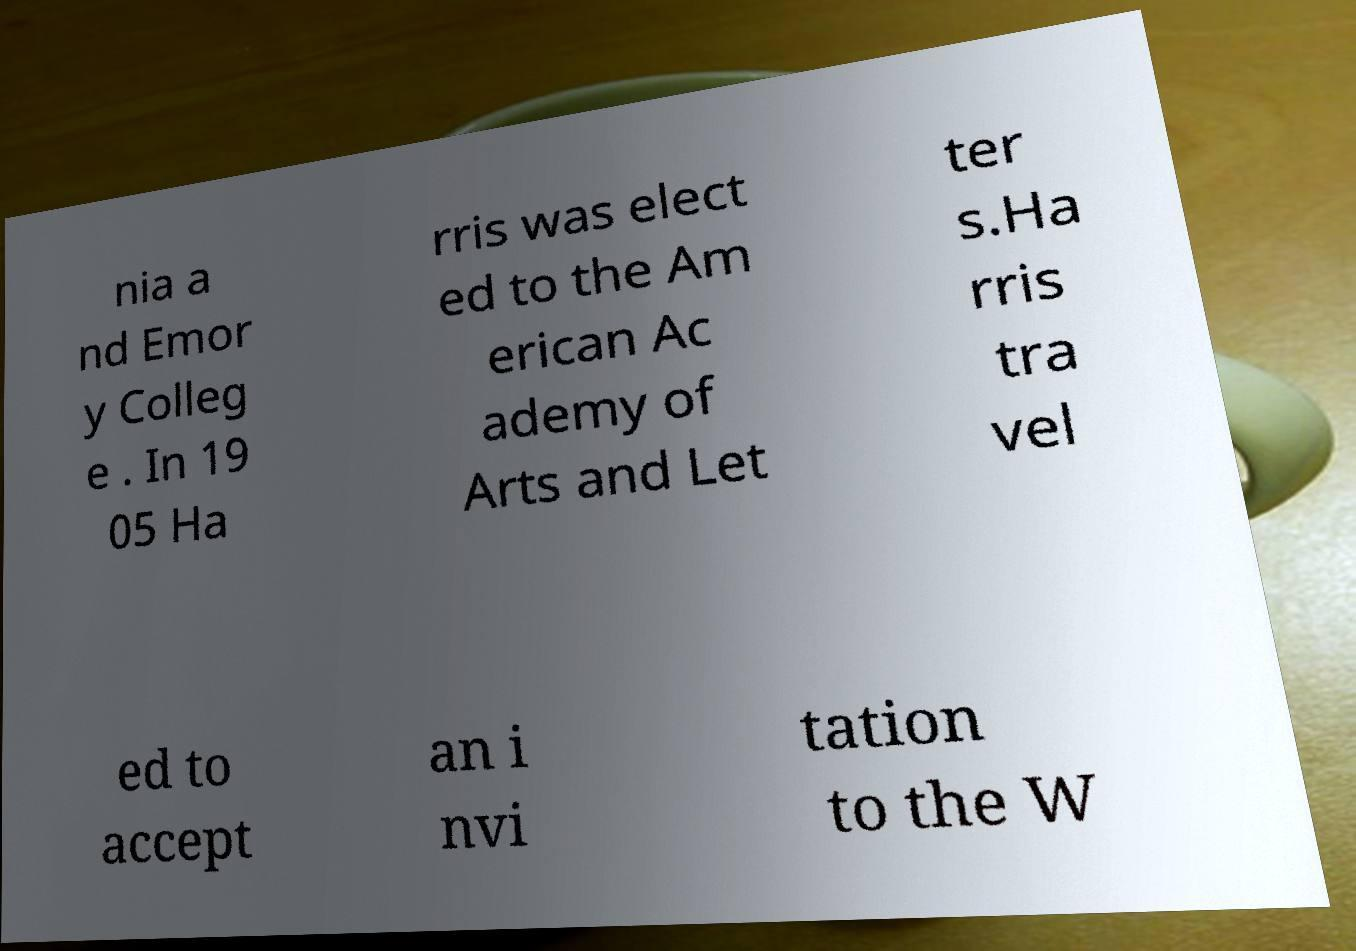Can you read and provide the text displayed in the image?This photo seems to have some interesting text. Can you extract and type it out for me? nia a nd Emor y Colleg e . In 19 05 Ha rris was elect ed to the Am erican Ac ademy of Arts and Let ter s.Ha rris tra vel ed to accept an i nvi tation to the W 